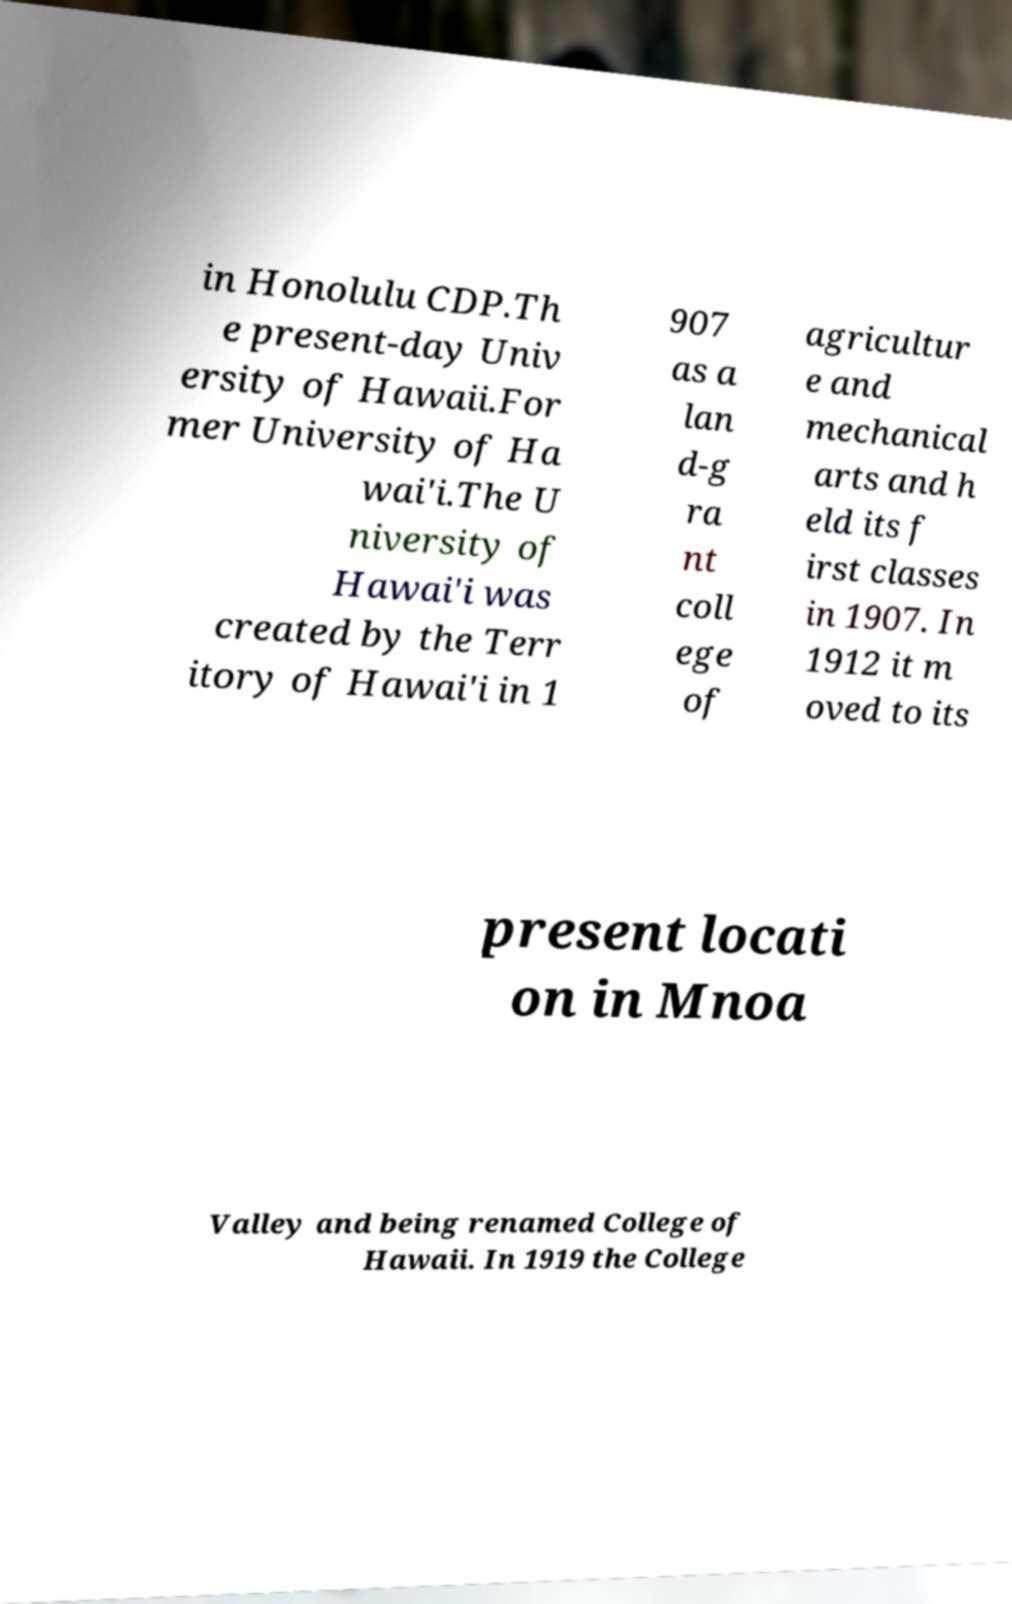What messages or text are displayed in this image? I need them in a readable, typed format. in Honolulu CDP.Th e present-day Univ ersity of Hawaii.For mer University of Ha wai'i.The U niversity of Hawai'i was created by the Terr itory of Hawai'i in 1 907 as a lan d-g ra nt coll ege of agricultur e and mechanical arts and h eld its f irst classes in 1907. In 1912 it m oved to its present locati on in Mnoa Valley and being renamed College of Hawaii. In 1919 the College 